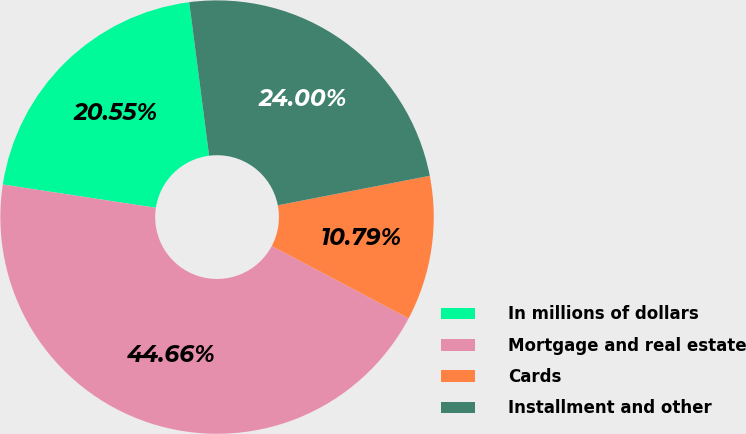Convert chart. <chart><loc_0><loc_0><loc_500><loc_500><pie_chart><fcel>In millions of dollars<fcel>Mortgage and real estate<fcel>Cards<fcel>Installment and other<nl><fcel>20.55%<fcel>44.66%<fcel>10.79%<fcel>24.0%<nl></chart> 